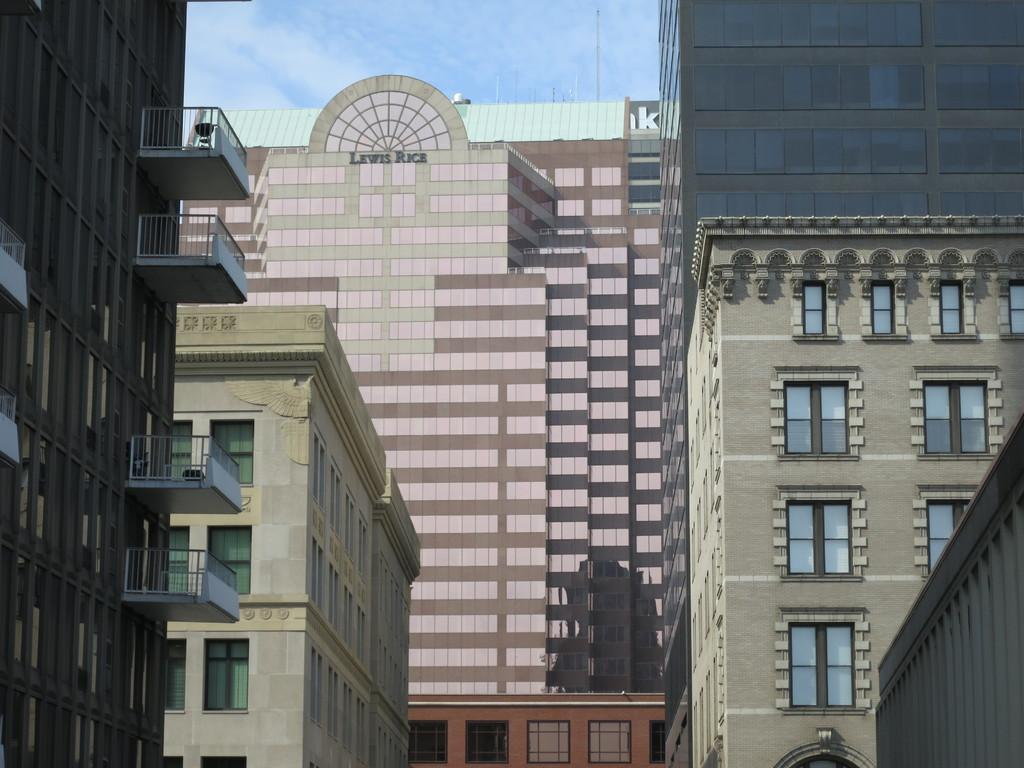What type of structures can be seen in the image? There are buildings in the image. What feature is present on the buildings? There are windows in the image. What type of barrier is visible in the image? There is a fence in the image. What is visible above the buildings and fence? The sky is visible in the image. What type of orange appliance can be seen in the image? There is no orange appliance present in the image. What is inside the box in the image? There is no box present in the image. 